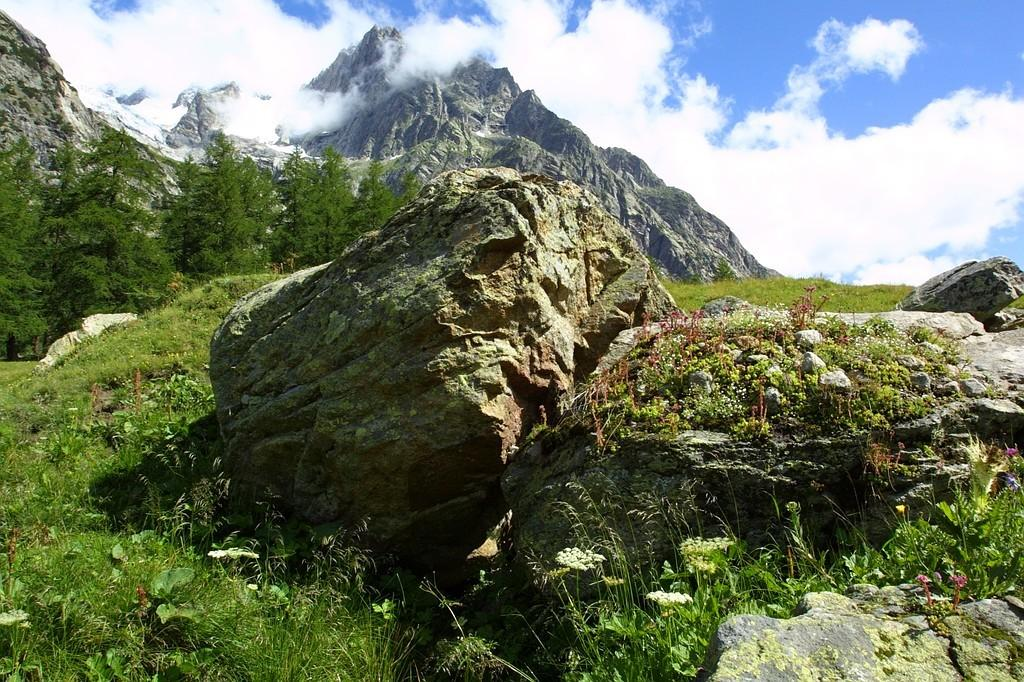What type of ground surface is visible in the image? The ground in the image is covered with grass and plants. What other objects can be seen on the ground? There are rocks on the ground. What can be seen in the background of the image? There are trees visible in the background. What type of landscape feature is visible in the distance? There are mountains in the distance. How would you describe the sky in the image? The sky is cloudy. What type of juice is being served on the sofa in the image? There is no sofa or juice present in the image. Can you tell me the name of the son who is playing near the trees in the image? There is no person, let alone a son, depicted in the image. 